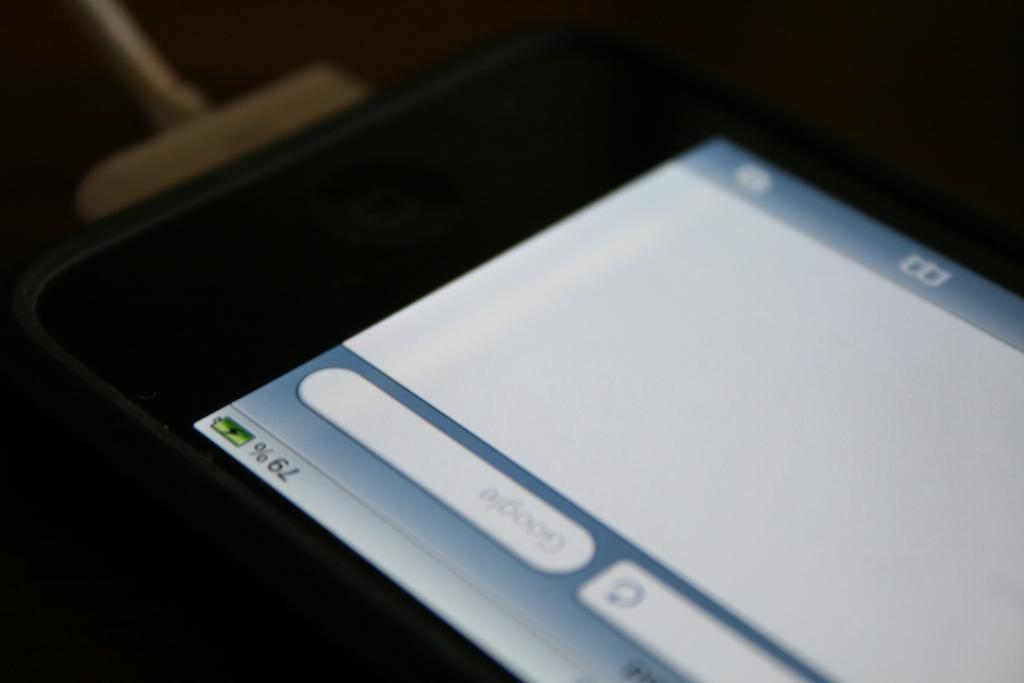<image>
Describe the image concisely. A phone is charging and is currently at 79% battery. 